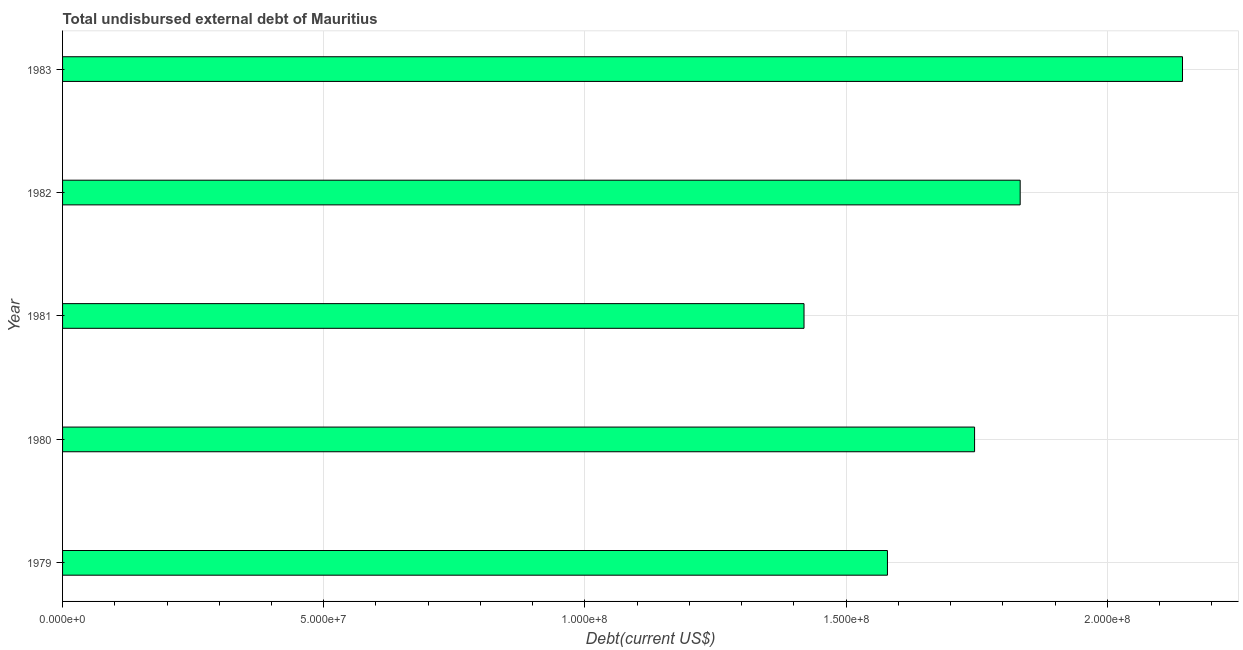Does the graph contain any zero values?
Keep it short and to the point. No. Does the graph contain grids?
Your answer should be very brief. Yes. What is the title of the graph?
Keep it short and to the point. Total undisbursed external debt of Mauritius. What is the label or title of the X-axis?
Keep it short and to the point. Debt(current US$). What is the total debt in 1982?
Provide a short and direct response. 1.83e+08. Across all years, what is the maximum total debt?
Offer a very short reply. 2.14e+08. Across all years, what is the minimum total debt?
Your answer should be very brief. 1.42e+08. In which year was the total debt maximum?
Keep it short and to the point. 1983. What is the sum of the total debt?
Keep it short and to the point. 8.72e+08. What is the difference between the total debt in 1982 and 1983?
Provide a short and direct response. -3.11e+07. What is the average total debt per year?
Your answer should be compact. 1.74e+08. What is the median total debt?
Offer a very short reply. 1.75e+08. Do a majority of the years between 1983 and 1979 (inclusive) have total debt greater than 170000000 US$?
Your answer should be compact. Yes. What is the ratio of the total debt in 1979 to that in 1983?
Offer a very short reply. 0.74. Is the difference between the total debt in 1982 and 1983 greater than the difference between any two years?
Offer a very short reply. No. What is the difference between the highest and the second highest total debt?
Make the answer very short. 3.11e+07. Is the sum of the total debt in 1979 and 1981 greater than the maximum total debt across all years?
Your answer should be very brief. Yes. What is the difference between the highest and the lowest total debt?
Your answer should be compact. 7.25e+07. Are all the bars in the graph horizontal?
Your answer should be compact. Yes. How many years are there in the graph?
Offer a very short reply. 5. What is the difference between two consecutive major ticks on the X-axis?
Give a very brief answer. 5.00e+07. Are the values on the major ticks of X-axis written in scientific E-notation?
Your answer should be compact. Yes. What is the Debt(current US$) of 1979?
Your response must be concise. 1.58e+08. What is the Debt(current US$) in 1980?
Your answer should be compact. 1.75e+08. What is the Debt(current US$) in 1981?
Provide a short and direct response. 1.42e+08. What is the Debt(current US$) in 1982?
Your answer should be very brief. 1.83e+08. What is the Debt(current US$) in 1983?
Give a very brief answer. 2.14e+08. What is the difference between the Debt(current US$) in 1979 and 1980?
Offer a terse response. -1.67e+07. What is the difference between the Debt(current US$) in 1979 and 1981?
Provide a short and direct response. 1.60e+07. What is the difference between the Debt(current US$) in 1979 and 1982?
Offer a terse response. -2.54e+07. What is the difference between the Debt(current US$) in 1979 and 1983?
Make the answer very short. -5.65e+07. What is the difference between the Debt(current US$) in 1980 and 1981?
Ensure brevity in your answer.  3.27e+07. What is the difference between the Debt(current US$) in 1980 and 1982?
Keep it short and to the point. -8.73e+06. What is the difference between the Debt(current US$) in 1980 and 1983?
Give a very brief answer. -3.98e+07. What is the difference between the Debt(current US$) in 1981 and 1982?
Your answer should be very brief. -4.14e+07. What is the difference between the Debt(current US$) in 1981 and 1983?
Keep it short and to the point. -7.25e+07. What is the difference between the Debt(current US$) in 1982 and 1983?
Ensure brevity in your answer.  -3.11e+07. What is the ratio of the Debt(current US$) in 1979 to that in 1980?
Give a very brief answer. 0.9. What is the ratio of the Debt(current US$) in 1979 to that in 1981?
Make the answer very short. 1.11. What is the ratio of the Debt(current US$) in 1979 to that in 1982?
Offer a very short reply. 0.86. What is the ratio of the Debt(current US$) in 1979 to that in 1983?
Your answer should be very brief. 0.74. What is the ratio of the Debt(current US$) in 1980 to that in 1981?
Provide a succinct answer. 1.23. What is the ratio of the Debt(current US$) in 1980 to that in 1982?
Offer a terse response. 0.95. What is the ratio of the Debt(current US$) in 1980 to that in 1983?
Keep it short and to the point. 0.81. What is the ratio of the Debt(current US$) in 1981 to that in 1982?
Provide a succinct answer. 0.77. What is the ratio of the Debt(current US$) in 1981 to that in 1983?
Give a very brief answer. 0.66. What is the ratio of the Debt(current US$) in 1982 to that in 1983?
Your response must be concise. 0.85. 